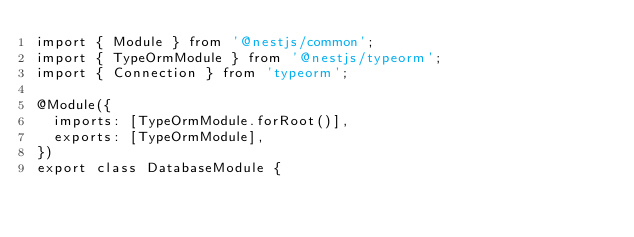Convert code to text. <code><loc_0><loc_0><loc_500><loc_500><_TypeScript_>import { Module } from '@nestjs/common';
import { TypeOrmModule } from '@nestjs/typeorm';
import { Connection } from 'typeorm';

@Module({
  imports: [TypeOrmModule.forRoot()],
  exports: [TypeOrmModule],
})
export class DatabaseModule {</code> 